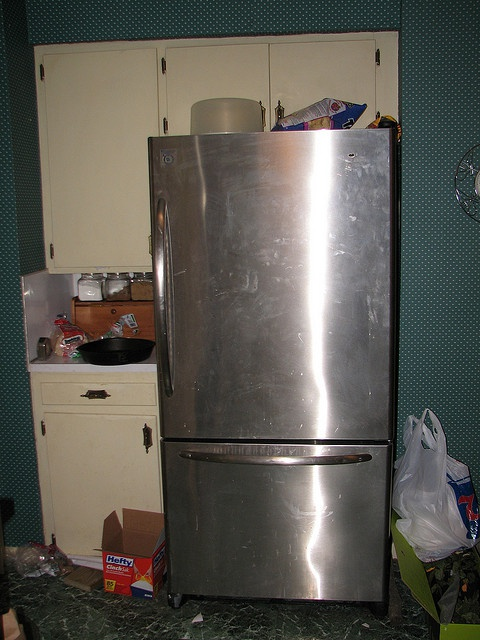Describe the objects in this image and their specific colors. I can see refrigerator in black, gray, darkgray, and white tones and bowl in black, gray, and darkgray tones in this image. 